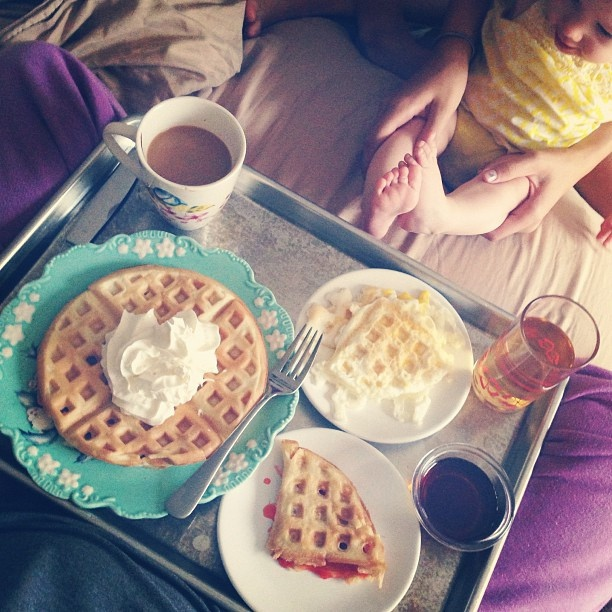Describe the objects in this image and their specific colors. I can see people in navy, brown, tan, and beige tones, cup in navy, gray, beige, and darkgray tones, people in navy, tan, lightpink, brown, and purple tones, sandwich in navy, tan, and brown tones, and cup in navy, brown, and tan tones in this image. 